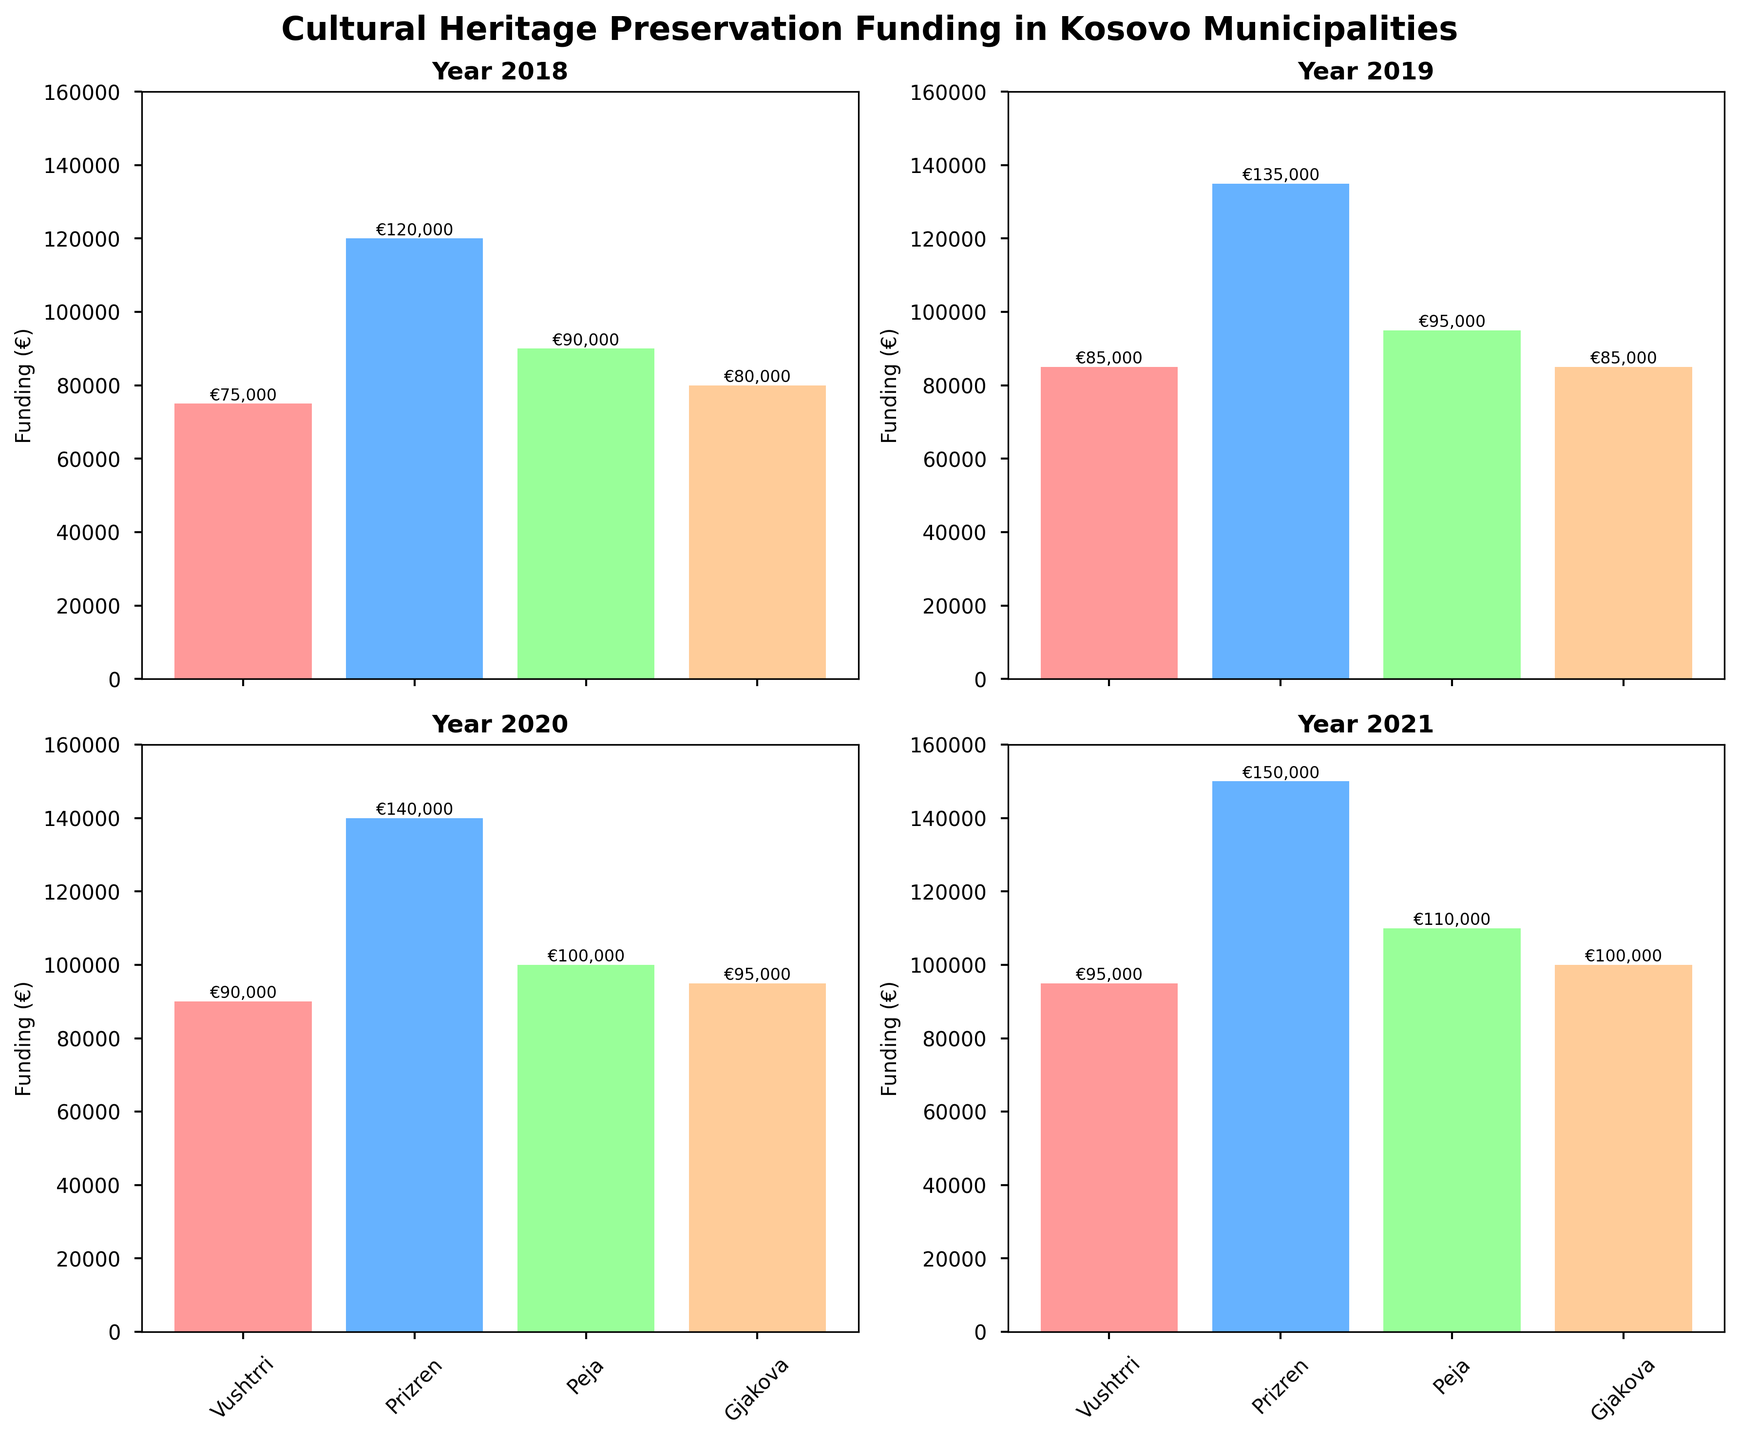what is the title of the figure? The title is located at the top of the figure and is usually in a bold font. It provides an overview of what the figure is about. In this case, it states the focus on funding for cultural heritage preservation.
Answer: Cultural Heritage Preservation Funding in Kosovo Municipalities Which municipality received the highest funding in 2021? To find this, we need to look at the subplot titled "Year 2021" and compare the heights of the bars representing the different municipalities. The highest bar corresponds to the highest funding.
Answer: Prizren How much funding did Vushtrri receive in 2020? This can be found by locating the "Year 2020" subplot and looking at the bar labeled "Vushtrri." The height of the bar (and any text on it) gives the funding amount.
Answer: €90,000 What is the difference in funding between Prizren and Peja in 2019? First, locate the "Year 2019" subplot and check the heights of the bars for Prizren and Peja. Subtract the funding amount for Peja from that of Prizren.
Answer: €40,000 Which year did Gjakova receive the highest funding? Compare the bars representing Gjakova across all four years. The highest bar will indicate the year in which Gjakova received the most funding.
Answer: 2021 Has Vushtrri's funding increased or decreased from 2018 to 2021? For this, we need to check the heights of the bars for Vushtrri in the "Year 2018" and "Year 2021" subplots. By comparing these, we can determine the trend.
Answer: Increased What is the total funding received by Peja over the four years? Sum up the heights (values) of the bars representing Peja across all four subplots: 2018, 2019, 2020, and 2021.
Answer: €375,000 Which municipality shows the most consistent funding from 2018 to 2021? To determine this, compare the bars across all years. The municipality with the bars having the least variation in height over the years shows the most consistent funding.
Answer: Gjakova What is the average funding received by Prizren across the four years? To find the average, sum up the funding amounts for Prizren across the four years and divide by 4. This involves adding the heights of the bars in 2018, 2019, 2020, and 2021, and then dividing by the number of years.
Answer: €136,250 